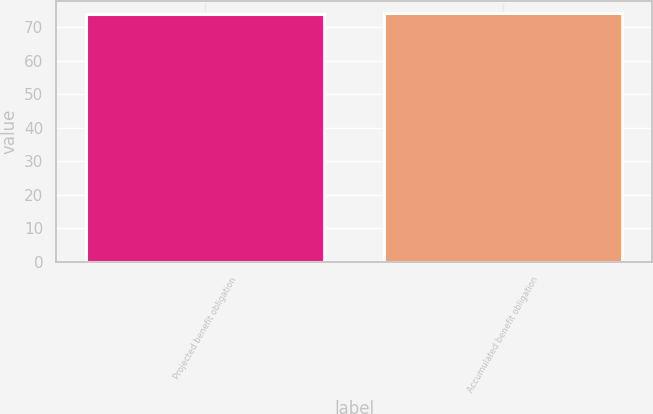<chart> <loc_0><loc_0><loc_500><loc_500><bar_chart><fcel>Projected benefit obligation<fcel>Accumulated benefit obligation<nl><fcel>74<fcel>74.1<nl></chart> 